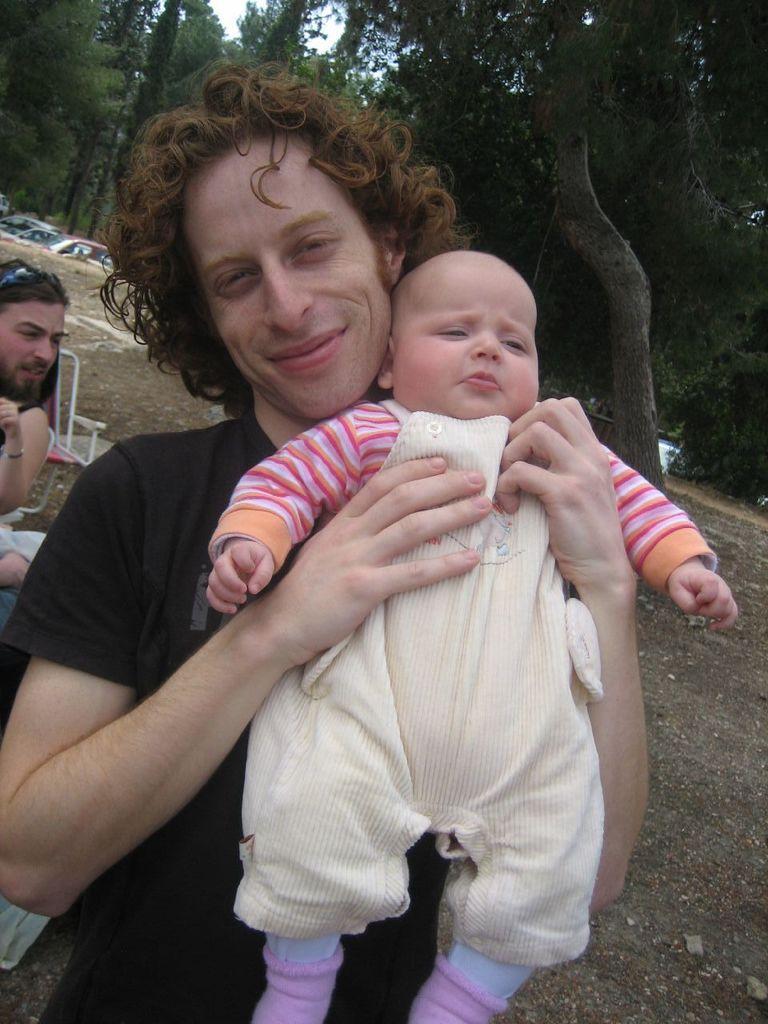Please provide a concise description of this image. In the foreground of the image we can see a person wearing black color T-shirt holding a kid in his hands and in the background of the image we can see some other persons, there are some trees and vehicles parked. 